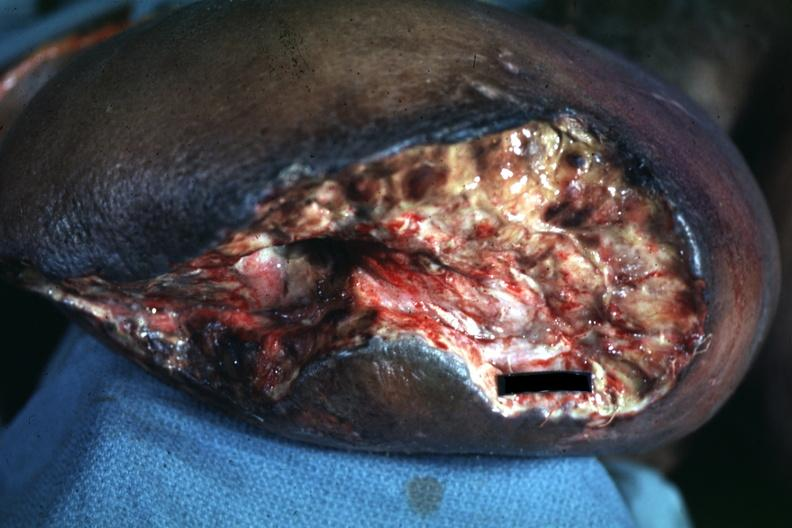s there present?
Answer the question using a single word or phrase. No 